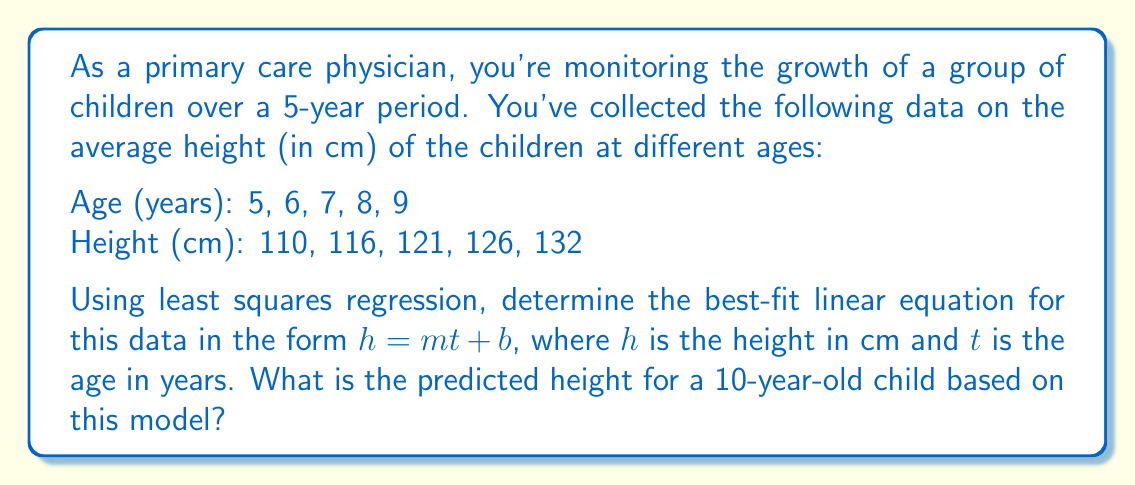Teach me how to tackle this problem. To find the best-fit linear equation using least squares regression, we need to calculate the slope $m$ and y-intercept $b$. Let's follow these steps:

1. Calculate the means of $t$ (age) and $h$ (height):
   $\bar{t} = \frac{5+6+7+8+9}{5} = 7$
   $\bar{h} = \frac{110+116+121+126+132}{5} = 121$

2. Calculate $S_{tt}$ and $S_{th}$:
   $S_{tt} = \sum(t_i - \bar{t})^2 = (-2)^2 + (-1)^2 + 0^2 + 1^2 + 2^2 = 10$
   $S_{th} = \sum(t_i - \bar{t})(h_i - \bar{h})$
   $= (-2)(-11) + (-1)(-5) + 0(0) + 1(5) + 2(11) = 55$

3. Calculate the slope $m$:
   $m = \frac{S_{th}}{S_{tt}} = \frac{55}{10} = 5.5$

4. Calculate the y-intercept $b$:
   $b = \bar{h} - m\bar{t} = 121 - 5.5(7) = 82.5$

5. The best-fit linear equation is:
   $h = 5.5t + 82.5$

6. To predict the height of a 10-year-old child, substitute $t=10$ into the equation:
   $h = 5.5(10) + 82.5 = 137.5$

Therefore, the predicted height for a 10-year-old child is 137.5 cm.
Answer: The best-fit linear equation is $h = 5.5t + 82.5$, and the predicted height for a 10-year-old child is 137.5 cm. 